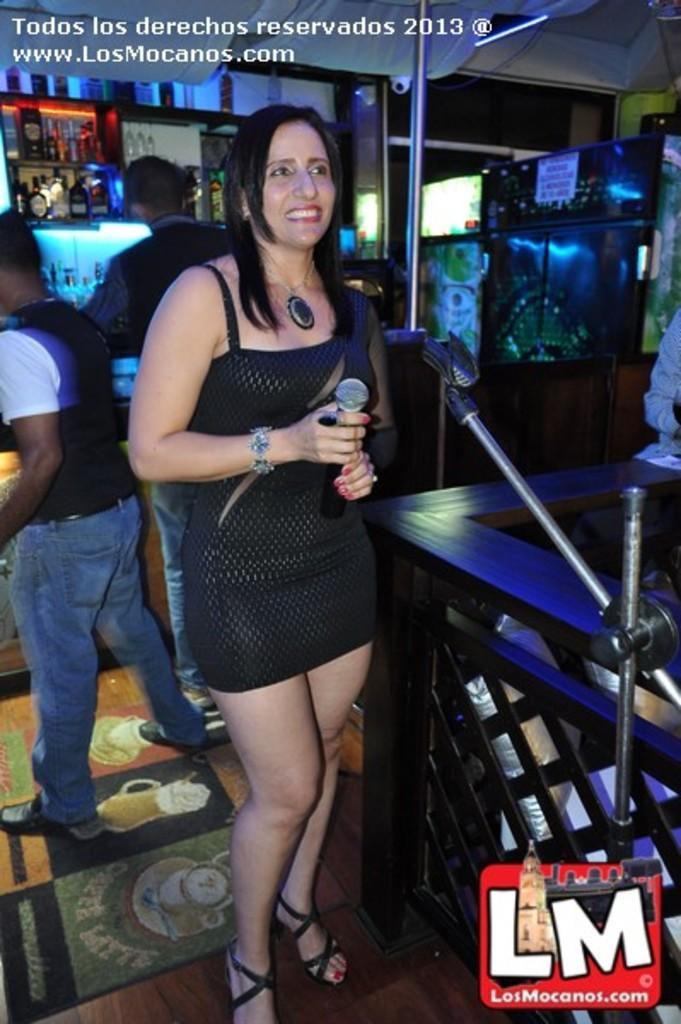What is the woman in the center of the image doing? The woman is standing with a mic in the center of the image. What can be seen in the background of the image? There are persons, bottles arranged in shelves, a refrigerator, and a wall in the background. Can you describe the arrangement of the bottles in the image? The bottles are arranged in shelves in the background. What type of appliance is present in the background? There is a refrigerator in the background. What type of locket is the woman wearing in the image? There is no locket visible on the woman in the image. How many rings can be seen on the woman's fingers in the image? There is no ring visible on the woman's fingers in the image. 